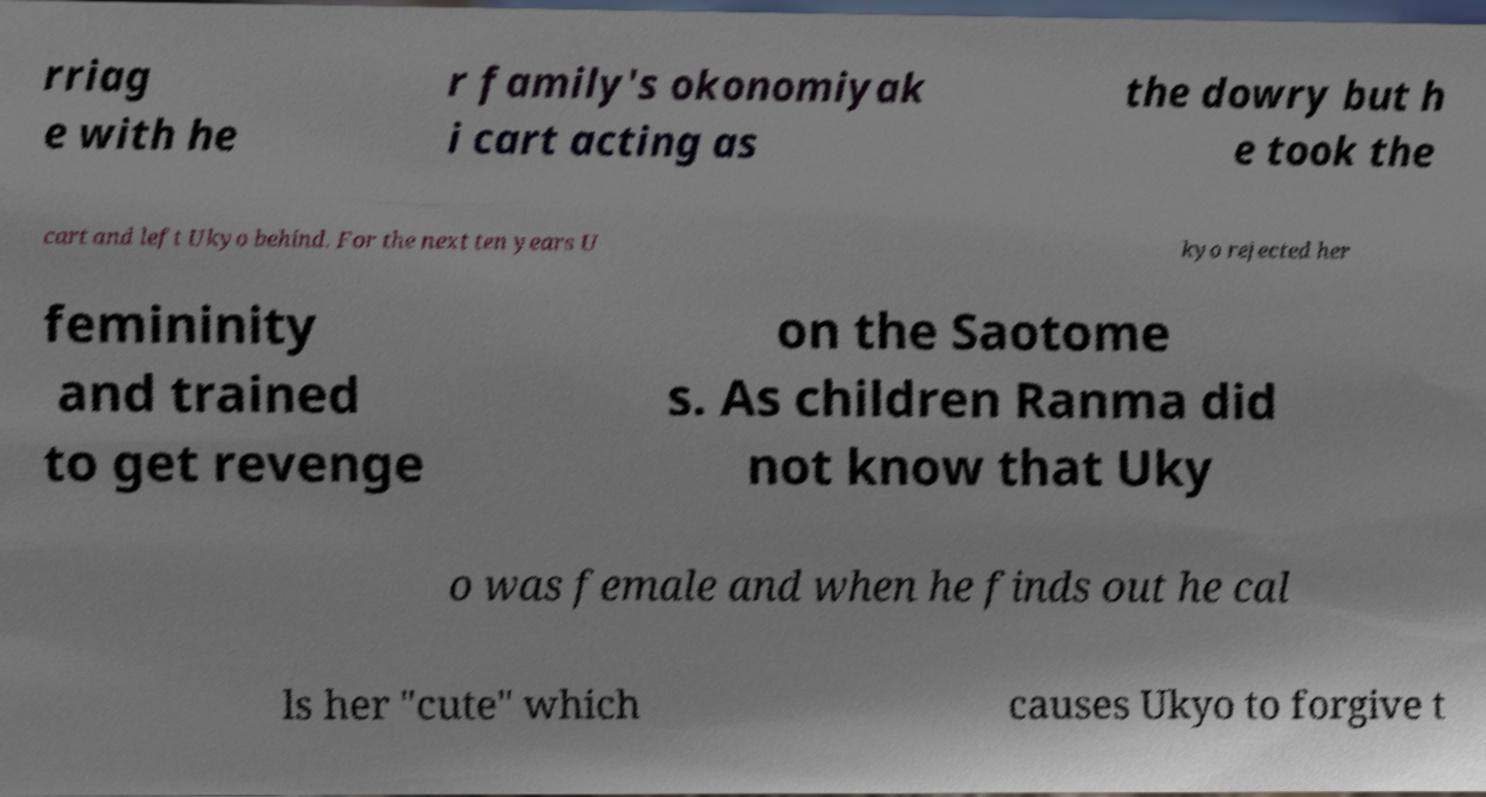What messages or text are displayed in this image? I need them in a readable, typed format. rriag e with he r family's okonomiyak i cart acting as the dowry but h e took the cart and left Ukyo behind. For the next ten years U kyo rejected her femininity and trained to get revenge on the Saotome s. As children Ranma did not know that Uky o was female and when he finds out he cal ls her "cute" which causes Ukyo to forgive t 